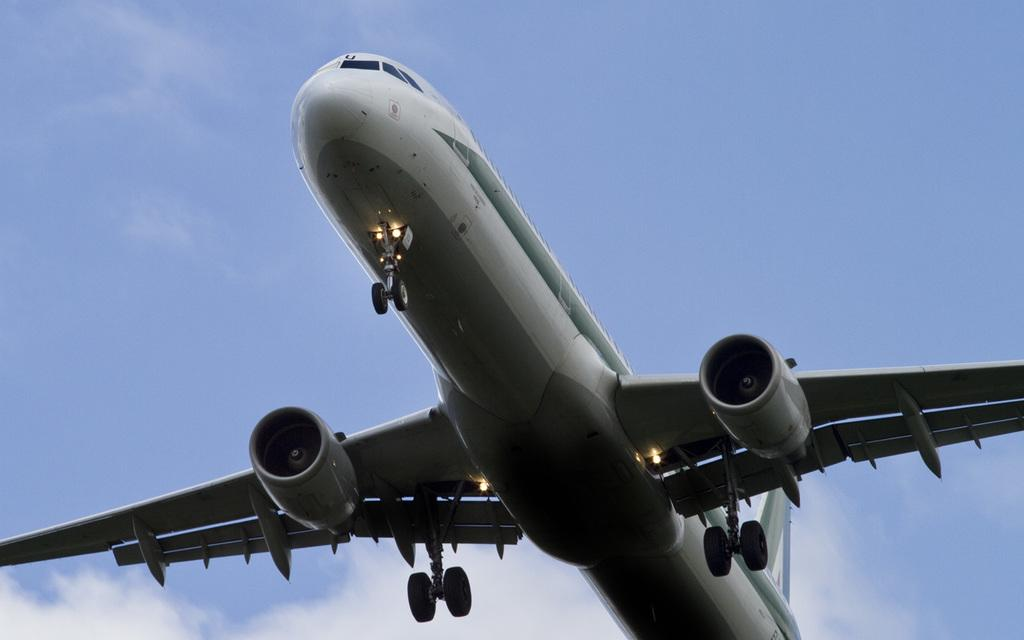What is the main subject of the image? The main subject of the image is an airplane. What is the airplane doing in the image? The airplane is flying in the sky. What type of eggnog is being served to the queen in the image? There is no eggnog or queen present in the image; it only features an airplane flying in the sky. 